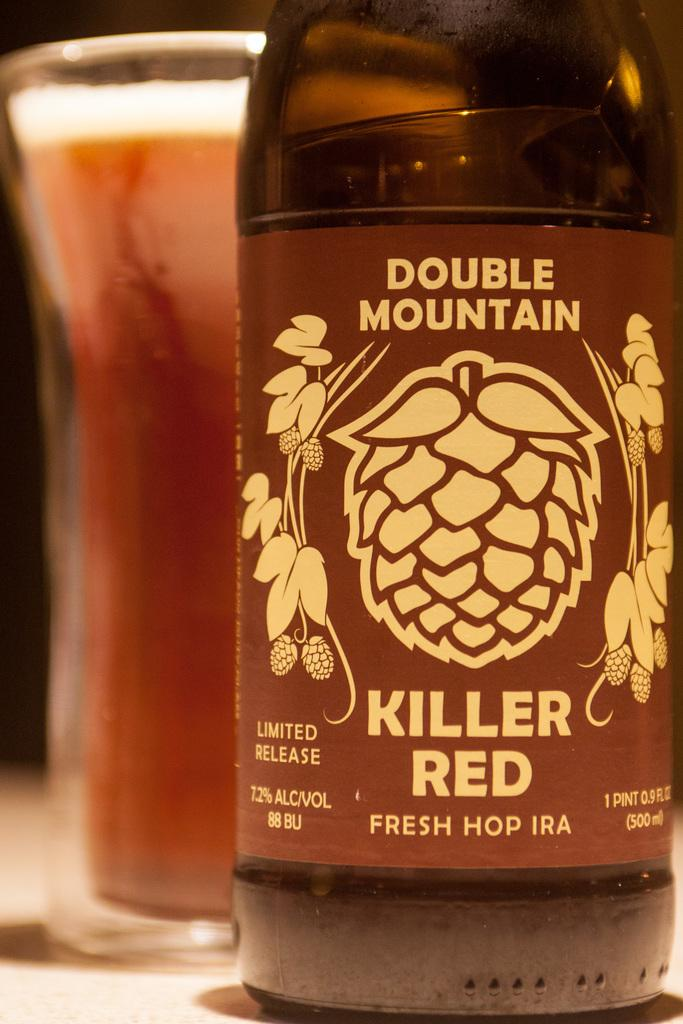<image>
Provide a brief description of the given image. A bottle of Killer Red is 7.2 percent alcohol. 